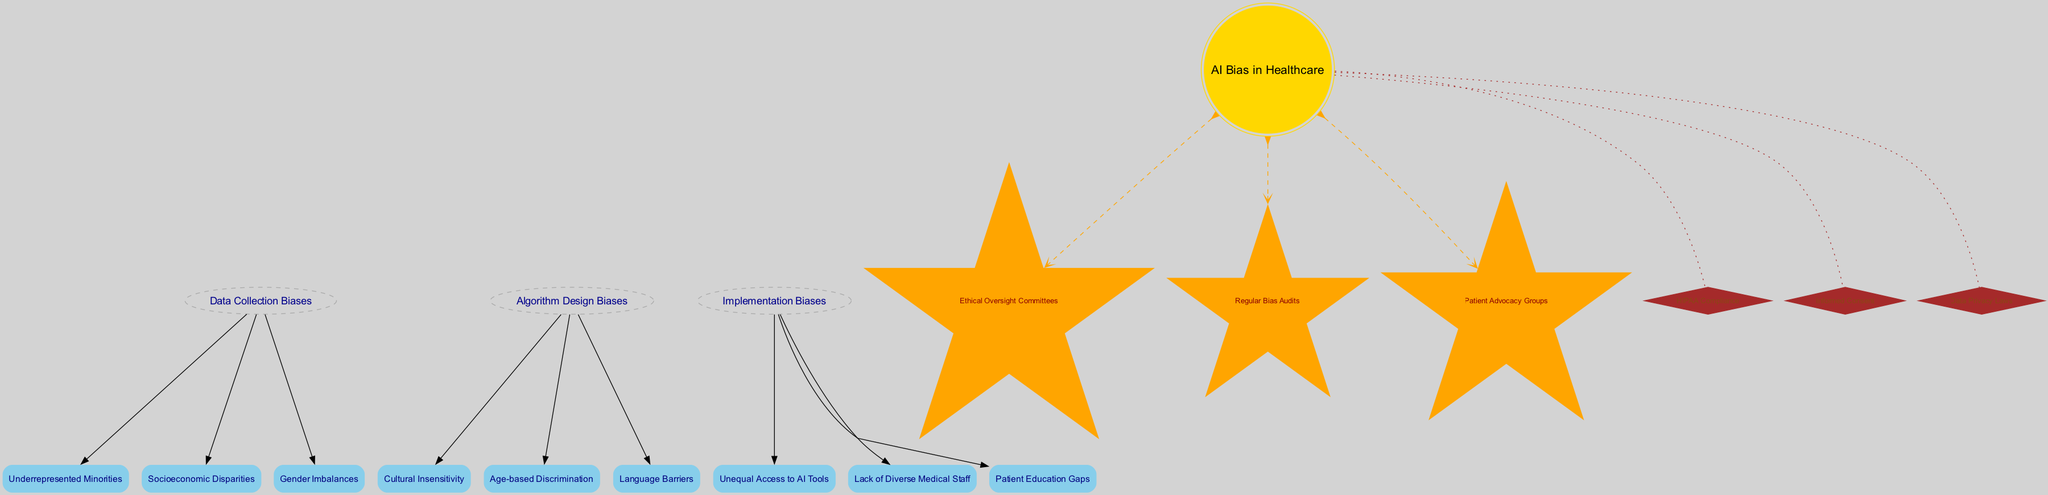What is the central body of the diagram? The diagram clearly identifies "AI Bias in Healthcare" as the central body, which is represented at the core of the illustration.
Answer: AI Bias in Healthcare How many satellites are associated with "Data Collection Biases"? Upon inspecting the "Data Collection Biases" orbit, there are three satellites listed: "Underrepresented Minorities," "Socioeconomic Disparities," and "Gender Imbalances."
Answer: 3 What type of node represents "Ethical Oversight Committees"? "Ethical Oversight Committees" is noted as a comet in the diagram, characterized by the star shape and color coding associated with comets.
Answer: Star Which bias category has "Lack of Diverse Medical Staff"? "Lack of Diverse Medical Staff" is listed under the "Implementation Biases" orbit, indicating its place within that specific category of biases.
Answer: Implementation Biases How many comets are present in the diagram? There are three comets identified: "Ethical Oversight Committees," "Regular Bias Audits," and "Patient Advocacy Groups," indicating the number of comets in the diagram.
Answer: 3 What is the relationship between "Cultural Insensitivity" and "AI Bias in Healthcare"? "Cultural Insensitivity" is a satellite that orbits around the "Algorithm Design Biases," which directly connects to the central body, "AI Bias in Healthcare," demonstrating its relevance to the central theme.
Answer: Algorithm Design Biases Which asteroid is specifically related to patient rights? "Informed Consent" is the asteroid that directly addresses aspects of patient rights within the context of healthcare and is featured prominently in the diagram.
Answer: Informed Consent What color represents the orbits in the diagram? The orbits are represented in dark grey, as indicated in the diagram's attributes for orbit nodes.
Answer: Dark Grey What does the dashed line between the central body and "Regular Bias Audits" signify? The dashed line indicates a connection or a relationship between "AI Bias in Healthcare" and "Regular Bias Audits," signifying that audits are a recurring theme linked to the central issue of AI bias.
Answer: Dashed Line 